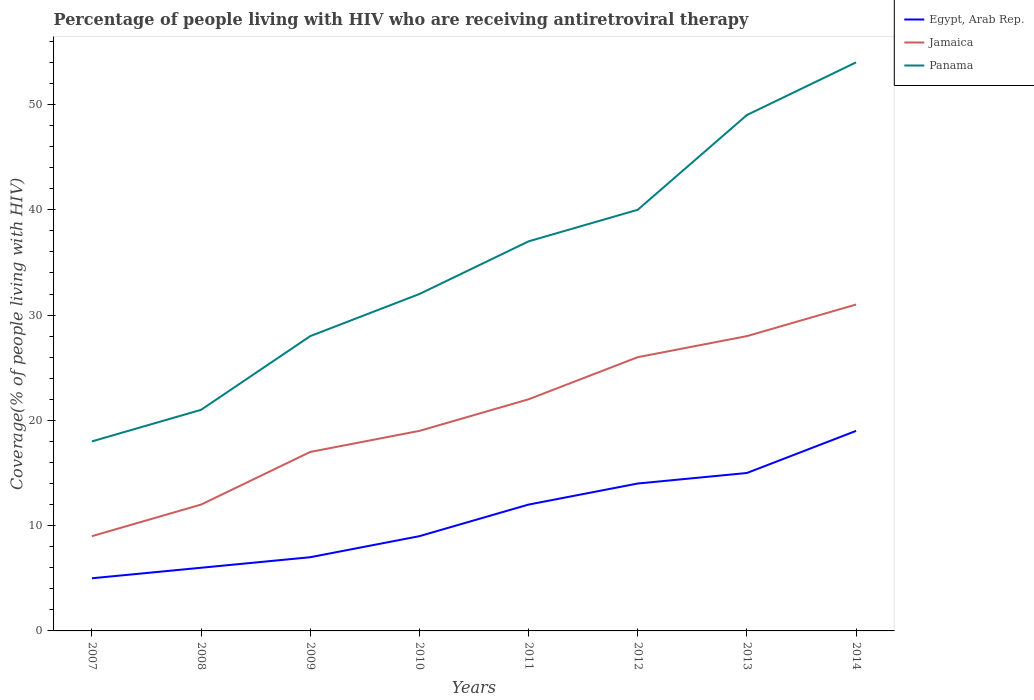How many different coloured lines are there?
Keep it short and to the point. 3. Is the number of lines equal to the number of legend labels?
Your answer should be very brief. Yes. Across all years, what is the maximum percentage of the HIV infected people who are receiving antiretroviral therapy in Panama?
Give a very brief answer. 18. What is the total percentage of the HIV infected people who are receiving antiretroviral therapy in Egypt, Arab Rep. in the graph?
Offer a terse response. -8. What is the difference between the highest and the second highest percentage of the HIV infected people who are receiving antiretroviral therapy in Panama?
Your response must be concise. 36. How many lines are there?
Your answer should be very brief. 3. Are the values on the major ticks of Y-axis written in scientific E-notation?
Give a very brief answer. No. Does the graph contain any zero values?
Your answer should be very brief. No. Does the graph contain grids?
Offer a terse response. No. Where does the legend appear in the graph?
Provide a short and direct response. Top right. How many legend labels are there?
Provide a short and direct response. 3. How are the legend labels stacked?
Ensure brevity in your answer.  Vertical. What is the title of the graph?
Offer a very short reply. Percentage of people living with HIV who are receiving antiretroviral therapy. What is the label or title of the Y-axis?
Your response must be concise. Coverage(% of people living with HIV). What is the Coverage(% of people living with HIV) in Egypt, Arab Rep. in 2007?
Provide a short and direct response. 5. What is the Coverage(% of people living with HIV) of Jamaica in 2007?
Your answer should be very brief. 9. What is the Coverage(% of people living with HIV) in Panama in 2007?
Your answer should be compact. 18. What is the Coverage(% of people living with HIV) of Egypt, Arab Rep. in 2008?
Provide a short and direct response. 6. What is the Coverage(% of people living with HIV) in Jamaica in 2009?
Ensure brevity in your answer.  17. What is the Coverage(% of people living with HIV) in Panama in 2009?
Your response must be concise. 28. What is the Coverage(% of people living with HIV) in Egypt, Arab Rep. in 2010?
Make the answer very short. 9. What is the Coverage(% of people living with HIV) in Panama in 2010?
Your answer should be compact. 32. What is the Coverage(% of people living with HIV) in Jamaica in 2011?
Provide a short and direct response. 22. What is the Coverage(% of people living with HIV) of Panama in 2011?
Offer a terse response. 37. What is the Coverage(% of people living with HIV) of Egypt, Arab Rep. in 2012?
Provide a short and direct response. 14. What is the Coverage(% of people living with HIV) in Panama in 2012?
Provide a short and direct response. 40. What is the Coverage(% of people living with HIV) of Egypt, Arab Rep. in 2013?
Give a very brief answer. 15. What is the Coverage(% of people living with HIV) in Jamaica in 2013?
Your answer should be very brief. 28. What is the Coverage(% of people living with HIV) in Panama in 2013?
Your response must be concise. 49. What is the Coverage(% of people living with HIV) in Jamaica in 2014?
Provide a short and direct response. 31. Across all years, what is the maximum Coverage(% of people living with HIV) of Jamaica?
Provide a succinct answer. 31. Across all years, what is the maximum Coverage(% of people living with HIV) in Panama?
Keep it short and to the point. 54. Across all years, what is the minimum Coverage(% of people living with HIV) in Jamaica?
Your answer should be very brief. 9. What is the total Coverage(% of people living with HIV) in Egypt, Arab Rep. in the graph?
Your answer should be compact. 87. What is the total Coverage(% of people living with HIV) in Jamaica in the graph?
Provide a succinct answer. 164. What is the total Coverage(% of people living with HIV) of Panama in the graph?
Provide a succinct answer. 279. What is the difference between the Coverage(% of people living with HIV) of Egypt, Arab Rep. in 2007 and that in 2008?
Offer a very short reply. -1. What is the difference between the Coverage(% of people living with HIV) of Panama in 2007 and that in 2008?
Keep it short and to the point. -3. What is the difference between the Coverage(% of people living with HIV) of Jamaica in 2007 and that in 2009?
Provide a succinct answer. -8. What is the difference between the Coverage(% of people living with HIV) in Egypt, Arab Rep. in 2007 and that in 2010?
Offer a terse response. -4. What is the difference between the Coverage(% of people living with HIV) in Jamaica in 2007 and that in 2010?
Offer a very short reply. -10. What is the difference between the Coverage(% of people living with HIV) of Egypt, Arab Rep. in 2007 and that in 2011?
Your answer should be compact. -7. What is the difference between the Coverage(% of people living with HIV) in Jamaica in 2007 and that in 2011?
Offer a very short reply. -13. What is the difference between the Coverage(% of people living with HIV) in Panama in 2007 and that in 2011?
Your answer should be very brief. -19. What is the difference between the Coverage(% of people living with HIV) of Jamaica in 2007 and that in 2012?
Your answer should be compact. -17. What is the difference between the Coverage(% of people living with HIV) of Panama in 2007 and that in 2012?
Your answer should be very brief. -22. What is the difference between the Coverage(% of people living with HIV) of Panama in 2007 and that in 2013?
Offer a terse response. -31. What is the difference between the Coverage(% of people living with HIV) in Egypt, Arab Rep. in 2007 and that in 2014?
Your answer should be compact. -14. What is the difference between the Coverage(% of people living with HIV) in Panama in 2007 and that in 2014?
Offer a terse response. -36. What is the difference between the Coverage(% of people living with HIV) of Jamaica in 2008 and that in 2009?
Your response must be concise. -5. What is the difference between the Coverage(% of people living with HIV) of Egypt, Arab Rep. in 2008 and that in 2010?
Keep it short and to the point. -3. What is the difference between the Coverage(% of people living with HIV) in Panama in 2008 and that in 2010?
Your answer should be very brief. -11. What is the difference between the Coverage(% of people living with HIV) of Jamaica in 2008 and that in 2011?
Offer a very short reply. -10. What is the difference between the Coverage(% of people living with HIV) of Egypt, Arab Rep. in 2008 and that in 2013?
Your response must be concise. -9. What is the difference between the Coverage(% of people living with HIV) of Jamaica in 2008 and that in 2013?
Make the answer very short. -16. What is the difference between the Coverage(% of people living with HIV) in Egypt, Arab Rep. in 2008 and that in 2014?
Provide a succinct answer. -13. What is the difference between the Coverage(% of people living with HIV) of Jamaica in 2008 and that in 2014?
Ensure brevity in your answer.  -19. What is the difference between the Coverage(% of people living with HIV) in Panama in 2008 and that in 2014?
Provide a succinct answer. -33. What is the difference between the Coverage(% of people living with HIV) in Jamaica in 2009 and that in 2010?
Provide a succinct answer. -2. What is the difference between the Coverage(% of people living with HIV) in Panama in 2009 and that in 2010?
Provide a short and direct response. -4. What is the difference between the Coverage(% of people living with HIV) in Jamaica in 2009 and that in 2011?
Your response must be concise. -5. What is the difference between the Coverage(% of people living with HIV) of Jamaica in 2009 and that in 2012?
Make the answer very short. -9. What is the difference between the Coverage(% of people living with HIV) in Panama in 2009 and that in 2012?
Ensure brevity in your answer.  -12. What is the difference between the Coverage(% of people living with HIV) in Egypt, Arab Rep. in 2009 and that in 2014?
Your response must be concise. -12. What is the difference between the Coverage(% of people living with HIV) in Jamaica in 2009 and that in 2014?
Give a very brief answer. -14. What is the difference between the Coverage(% of people living with HIV) of Jamaica in 2010 and that in 2011?
Make the answer very short. -3. What is the difference between the Coverage(% of people living with HIV) in Egypt, Arab Rep. in 2010 and that in 2012?
Offer a very short reply. -5. What is the difference between the Coverage(% of people living with HIV) of Jamaica in 2010 and that in 2012?
Give a very brief answer. -7. What is the difference between the Coverage(% of people living with HIV) in Jamaica in 2010 and that in 2013?
Your answer should be compact. -9. What is the difference between the Coverage(% of people living with HIV) of Panama in 2010 and that in 2013?
Provide a succinct answer. -17. What is the difference between the Coverage(% of people living with HIV) in Egypt, Arab Rep. in 2010 and that in 2014?
Your answer should be compact. -10. What is the difference between the Coverage(% of people living with HIV) in Panama in 2010 and that in 2014?
Ensure brevity in your answer.  -22. What is the difference between the Coverage(% of people living with HIV) in Jamaica in 2011 and that in 2012?
Offer a terse response. -4. What is the difference between the Coverage(% of people living with HIV) of Jamaica in 2011 and that in 2013?
Keep it short and to the point. -6. What is the difference between the Coverage(% of people living with HIV) of Egypt, Arab Rep. in 2011 and that in 2014?
Your answer should be compact. -7. What is the difference between the Coverage(% of people living with HIV) in Jamaica in 2012 and that in 2013?
Give a very brief answer. -2. What is the difference between the Coverage(% of people living with HIV) of Panama in 2012 and that in 2013?
Make the answer very short. -9. What is the difference between the Coverage(% of people living with HIV) of Egypt, Arab Rep. in 2012 and that in 2014?
Offer a very short reply. -5. What is the difference between the Coverage(% of people living with HIV) of Jamaica in 2012 and that in 2014?
Offer a very short reply. -5. What is the difference between the Coverage(% of people living with HIV) of Jamaica in 2013 and that in 2014?
Provide a short and direct response. -3. What is the difference between the Coverage(% of people living with HIV) in Panama in 2013 and that in 2014?
Offer a terse response. -5. What is the difference between the Coverage(% of people living with HIV) in Egypt, Arab Rep. in 2007 and the Coverage(% of people living with HIV) in Jamaica in 2008?
Give a very brief answer. -7. What is the difference between the Coverage(% of people living with HIV) in Egypt, Arab Rep. in 2007 and the Coverage(% of people living with HIV) in Jamaica in 2009?
Your response must be concise. -12. What is the difference between the Coverage(% of people living with HIV) of Egypt, Arab Rep. in 2007 and the Coverage(% of people living with HIV) of Panama in 2009?
Your response must be concise. -23. What is the difference between the Coverage(% of people living with HIV) of Jamaica in 2007 and the Coverage(% of people living with HIV) of Panama in 2010?
Your answer should be compact. -23. What is the difference between the Coverage(% of people living with HIV) in Egypt, Arab Rep. in 2007 and the Coverage(% of people living with HIV) in Jamaica in 2011?
Your answer should be very brief. -17. What is the difference between the Coverage(% of people living with HIV) of Egypt, Arab Rep. in 2007 and the Coverage(% of people living with HIV) of Panama in 2011?
Offer a terse response. -32. What is the difference between the Coverage(% of people living with HIV) of Egypt, Arab Rep. in 2007 and the Coverage(% of people living with HIV) of Panama in 2012?
Ensure brevity in your answer.  -35. What is the difference between the Coverage(% of people living with HIV) of Jamaica in 2007 and the Coverage(% of people living with HIV) of Panama in 2012?
Give a very brief answer. -31. What is the difference between the Coverage(% of people living with HIV) in Egypt, Arab Rep. in 2007 and the Coverage(% of people living with HIV) in Jamaica in 2013?
Your answer should be very brief. -23. What is the difference between the Coverage(% of people living with HIV) of Egypt, Arab Rep. in 2007 and the Coverage(% of people living with HIV) of Panama in 2013?
Your response must be concise. -44. What is the difference between the Coverage(% of people living with HIV) in Jamaica in 2007 and the Coverage(% of people living with HIV) in Panama in 2013?
Keep it short and to the point. -40. What is the difference between the Coverage(% of people living with HIV) of Egypt, Arab Rep. in 2007 and the Coverage(% of people living with HIV) of Jamaica in 2014?
Make the answer very short. -26. What is the difference between the Coverage(% of people living with HIV) in Egypt, Arab Rep. in 2007 and the Coverage(% of people living with HIV) in Panama in 2014?
Give a very brief answer. -49. What is the difference between the Coverage(% of people living with HIV) in Jamaica in 2007 and the Coverage(% of people living with HIV) in Panama in 2014?
Provide a succinct answer. -45. What is the difference between the Coverage(% of people living with HIV) in Egypt, Arab Rep. in 2008 and the Coverage(% of people living with HIV) in Jamaica in 2010?
Your answer should be compact. -13. What is the difference between the Coverage(% of people living with HIV) of Egypt, Arab Rep. in 2008 and the Coverage(% of people living with HIV) of Panama in 2010?
Ensure brevity in your answer.  -26. What is the difference between the Coverage(% of people living with HIV) in Jamaica in 2008 and the Coverage(% of people living with HIV) in Panama in 2010?
Keep it short and to the point. -20. What is the difference between the Coverage(% of people living with HIV) of Egypt, Arab Rep. in 2008 and the Coverage(% of people living with HIV) of Jamaica in 2011?
Ensure brevity in your answer.  -16. What is the difference between the Coverage(% of people living with HIV) of Egypt, Arab Rep. in 2008 and the Coverage(% of people living with HIV) of Panama in 2011?
Your answer should be compact. -31. What is the difference between the Coverage(% of people living with HIV) in Egypt, Arab Rep. in 2008 and the Coverage(% of people living with HIV) in Panama in 2012?
Provide a short and direct response. -34. What is the difference between the Coverage(% of people living with HIV) of Egypt, Arab Rep. in 2008 and the Coverage(% of people living with HIV) of Jamaica in 2013?
Your response must be concise. -22. What is the difference between the Coverage(% of people living with HIV) of Egypt, Arab Rep. in 2008 and the Coverage(% of people living with HIV) of Panama in 2013?
Give a very brief answer. -43. What is the difference between the Coverage(% of people living with HIV) in Jamaica in 2008 and the Coverage(% of people living with HIV) in Panama in 2013?
Your response must be concise. -37. What is the difference between the Coverage(% of people living with HIV) of Egypt, Arab Rep. in 2008 and the Coverage(% of people living with HIV) of Jamaica in 2014?
Offer a very short reply. -25. What is the difference between the Coverage(% of people living with HIV) of Egypt, Arab Rep. in 2008 and the Coverage(% of people living with HIV) of Panama in 2014?
Your answer should be compact. -48. What is the difference between the Coverage(% of people living with HIV) of Jamaica in 2008 and the Coverage(% of people living with HIV) of Panama in 2014?
Ensure brevity in your answer.  -42. What is the difference between the Coverage(% of people living with HIV) in Egypt, Arab Rep. in 2009 and the Coverage(% of people living with HIV) in Panama in 2010?
Offer a terse response. -25. What is the difference between the Coverage(% of people living with HIV) of Egypt, Arab Rep. in 2009 and the Coverage(% of people living with HIV) of Jamaica in 2011?
Provide a short and direct response. -15. What is the difference between the Coverage(% of people living with HIV) in Egypt, Arab Rep. in 2009 and the Coverage(% of people living with HIV) in Panama in 2011?
Keep it short and to the point. -30. What is the difference between the Coverage(% of people living with HIV) in Egypt, Arab Rep. in 2009 and the Coverage(% of people living with HIV) in Panama in 2012?
Your response must be concise. -33. What is the difference between the Coverage(% of people living with HIV) in Egypt, Arab Rep. in 2009 and the Coverage(% of people living with HIV) in Jamaica in 2013?
Provide a succinct answer. -21. What is the difference between the Coverage(% of people living with HIV) in Egypt, Arab Rep. in 2009 and the Coverage(% of people living with HIV) in Panama in 2013?
Keep it short and to the point. -42. What is the difference between the Coverage(% of people living with HIV) in Jamaica in 2009 and the Coverage(% of people living with HIV) in Panama in 2013?
Your answer should be very brief. -32. What is the difference between the Coverage(% of people living with HIV) of Egypt, Arab Rep. in 2009 and the Coverage(% of people living with HIV) of Panama in 2014?
Your answer should be very brief. -47. What is the difference between the Coverage(% of people living with HIV) of Jamaica in 2009 and the Coverage(% of people living with HIV) of Panama in 2014?
Ensure brevity in your answer.  -37. What is the difference between the Coverage(% of people living with HIV) of Egypt, Arab Rep. in 2010 and the Coverage(% of people living with HIV) of Panama in 2011?
Provide a short and direct response. -28. What is the difference between the Coverage(% of people living with HIV) in Egypt, Arab Rep. in 2010 and the Coverage(% of people living with HIV) in Panama in 2012?
Make the answer very short. -31. What is the difference between the Coverage(% of people living with HIV) of Egypt, Arab Rep. in 2010 and the Coverage(% of people living with HIV) of Jamaica in 2013?
Ensure brevity in your answer.  -19. What is the difference between the Coverage(% of people living with HIV) of Egypt, Arab Rep. in 2010 and the Coverage(% of people living with HIV) of Panama in 2013?
Your answer should be compact. -40. What is the difference between the Coverage(% of people living with HIV) in Jamaica in 2010 and the Coverage(% of people living with HIV) in Panama in 2013?
Give a very brief answer. -30. What is the difference between the Coverage(% of people living with HIV) in Egypt, Arab Rep. in 2010 and the Coverage(% of people living with HIV) in Jamaica in 2014?
Your answer should be very brief. -22. What is the difference between the Coverage(% of people living with HIV) of Egypt, Arab Rep. in 2010 and the Coverage(% of people living with HIV) of Panama in 2014?
Make the answer very short. -45. What is the difference between the Coverage(% of people living with HIV) in Jamaica in 2010 and the Coverage(% of people living with HIV) in Panama in 2014?
Your answer should be compact. -35. What is the difference between the Coverage(% of people living with HIV) of Egypt, Arab Rep. in 2011 and the Coverage(% of people living with HIV) of Panama in 2012?
Make the answer very short. -28. What is the difference between the Coverage(% of people living with HIV) in Egypt, Arab Rep. in 2011 and the Coverage(% of people living with HIV) in Panama in 2013?
Your response must be concise. -37. What is the difference between the Coverage(% of people living with HIV) in Jamaica in 2011 and the Coverage(% of people living with HIV) in Panama in 2013?
Ensure brevity in your answer.  -27. What is the difference between the Coverage(% of people living with HIV) in Egypt, Arab Rep. in 2011 and the Coverage(% of people living with HIV) in Panama in 2014?
Make the answer very short. -42. What is the difference between the Coverage(% of people living with HIV) of Jamaica in 2011 and the Coverage(% of people living with HIV) of Panama in 2014?
Keep it short and to the point. -32. What is the difference between the Coverage(% of people living with HIV) in Egypt, Arab Rep. in 2012 and the Coverage(% of people living with HIV) in Jamaica in 2013?
Your response must be concise. -14. What is the difference between the Coverage(% of people living with HIV) of Egypt, Arab Rep. in 2012 and the Coverage(% of people living with HIV) of Panama in 2013?
Give a very brief answer. -35. What is the difference between the Coverage(% of people living with HIV) in Jamaica in 2012 and the Coverage(% of people living with HIV) in Panama in 2013?
Provide a short and direct response. -23. What is the difference between the Coverage(% of people living with HIV) in Egypt, Arab Rep. in 2012 and the Coverage(% of people living with HIV) in Jamaica in 2014?
Ensure brevity in your answer.  -17. What is the difference between the Coverage(% of people living with HIV) in Egypt, Arab Rep. in 2012 and the Coverage(% of people living with HIV) in Panama in 2014?
Offer a terse response. -40. What is the difference between the Coverage(% of people living with HIV) in Jamaica in 2012 and the Coverage(% of people living with HIV) in Panama in 2014?
Your response must be concise. -28. What is the difference between the Coverage(% of people living with HIV) of Egypt, Arab Rep. in 2013 and the Coverage(% of people living with HIV) of Jamaica in 2014?
Make the answer very short. -16. What is the difference between the Coverage(% of people living with HIV) in Egypt, Arab Rep. in 2013 and the Coverage(% of people living with HIV) in Panama in 2014?
Your answer should be compact. -39. What is the average Coverage(% of people living with HIV) of Egypt, Arab Rep. per year?
Your response must be concise. 10.88. What is the average Coverage(% of people living with HIV) of Jamaica per year?
Keep it short and to the point. 20.5. What is the average Coverage(% of people living with HIV) in Panama per year?
Offer a very short reply. 34.88. In the year 2007, what is the difference between the Coverage(% of people living with HIV) in Egypt, Arab Rep. and Coverage(% of people living with HIV) in Jamaica?
Ensure brevity in your answer.  -4. In the year 2007, what is the difference between the Coverage(% of people living with HIV) in Egypt, Arab Rep. and Coverage(% of people living with HIV) in Panama?
Your response must be concise. -13. In the year 2008, what is the difference between the Coverage(% of people living with HIV) of Egypt, Arab Rep. and Coverage(% of people living with HIV) of Panama?
Offer a terse response. -15. In the year 2008, what is the difference between the Coverage(% of people living with HIV) of Jamaica and Coverage(% of people living with HIV) of Panama?
Give a very brief answer. -9. In the year 2009, what is the difference between the Coverage(% of people living with HIV) in Egypt, Arab Rep. and Coverage(% of people living with HIV) in Jamaica?
Offer a terse response. -10. In the year 2009, what is the difference between the Coverage(% of people living with HIV) in Egypt, Arab Rep. and Coverage(% of people living with HIV) in Panama?
Your answer should be compact. -21. In the year 2009, what is the difference between the Coverage(% of people living with HIV) of Jamaica and Coverage(% of people living with HIV) of Panama?
Provide a short and direct response. -11. In the year 2010, what is the difference between the Coverage(% of people living with HIV) of Jamaica and Coverage(% of people living with HIV) of Panama?
Your response must be concise. -13. In the year 2011, what is the difference between the Coverage(% of people living with HIV) in Egypt, Arab Rep. and Coverage(% of people living with HIV) in Jamaica?
Make the answer very short. -10. In the year 2011, what is the difference between the Coverage(% of people living with HIV) of Egypt, Arab Rep. and Coverage(% of people living with HIV) of Panama?
Your answer should be compact. -25. In the year 2012, what is the difference between the Coverage(% of people living with HIV) of Egypt, Arab Rep. and Coverage(% of people living with HIV) of Panama?
Offer a very short reply. -26. In the year 2012, what is the difference between the Coverage(% of people living with HIV) of Jamaica and Coverage(% of people living with HIV) of Panama?
Keep it short and to the point. -14. In the year 2013, what is the difference between the Coverage(% of people living with HIV) in Egypt, Arab Rep. and Coverage(% of people living with HIV) in Jamaica?
Your answer should be very brief. -13. In the year 2013, what is the difference between the Coverage(% of people living with HIV) in Egypt, Arab Rep. and Coverage(% of people living with HIV) in Panama?
Give a very brief answer. -34. In the year 2014, what is the difference between the Coverage(% of people living with HIV) of Egypt, Arab Rep. and Coverage(% of people living with HIV) of Jamaica?
Offer a very short reply. -12. In the year 2014, what is the difference between the Coverage(% of people living with HIV) of Egypt, Arab Rep. and Coverage(% of people living with HIV) of Panama?
Offer a very short reply. -35. What is the ratio of the Coverage(% of people living with HIV) in Egypt, Arab Rep. in 2007 to that in 2008?
Give a very brief answer. 0.83. What is the ratio of the Coverage(% of people living with HIV) in Jamaica in 2007 to that in 2008?
Offer a very short reply. 0.75. What is the ratio of the Coverage(% of people living with HIV) of Egypt, Arab Rep. in 2007 to that in 2009?
Your answer should be compact. 0.71. What is the ratio of the Coverage(% of people living with HIV) of Jamaica in 2007 to that in 2009?
Your answer should be compact. 0.53. What is the ratio of the Coverage(% of people living with HIV) in Panama in 2007 to that in 2009?
Provide a short and direct response. 0.64. What is the ratio of the Coverage(% of people living with HIV) in Egypt, Arab Rep. in 2007 to that in 2010?
Your answer should be compact. 0.56. What is the ratio of the Coverage(% of people living with HIV) of Jamaica in 2007 to that in 2010?
Make the answer very short. 0.47. What is the ratio of the Coverage(% of people living with HIV) of Panama in 2007 to that in 2010?
Your response must be concise. 0.56. What is the ratio of the Coverage(% of people living with HIV) of Egypt, Arab Rep. in 2007 to that in 2011?
Ensure brevity in your answer.  0.42. What is the ratio of the Coverage(% of people living with HIV) in Jamaica in 2007 to that in 2011?
Your response must be concise. 0.41. What is the ratio of the Coverage(% of people living with HIV) in Panama in 2007 to that in 2011?
Give a very brief answer. 0.49. What is the ratio of the Coverage(% of people living with HIV) of Egypt, Arab Rep. in 2007 to that in 2012?
Offer a very short reply. 0.36. What is the ratio of the Coverage(% of people living with HIV) in Jamaica in 2007 to that in 2012?
Make the answer very short. 0.35. What is the ratio of the Coverage(% of people living with HIV) of Panama in 2007 to that in 2012?
Offer a terse response. 0.45. What is the ratio of the Coverage(% of people living with HIV) of Jamaica in 2007 to that in 2013?
Make the answer very short. 0.32. What is the ratio of the Coverage(% of people living with HIV) in Panama in 2007 to that in 2013?
Your answer should be very brief. 0.37. What is the ratio of the Coverage(% of people living with HIV) of Egypt, Arab Rep. in 2007 to that in 2014?
Give a very brief answer. 0.26. What is the ratio of the Coverage(% of people living with HIV) of Jamaica in 2007 to that in 2014?
Give a very brief answer. 0.29. What is the ratio of the Coverage(% of people living with HIV) of Egypt, Arab Rep. in 2008 to that in 2009?
Give a very brief answer. 0.86. What is the ratio of the Coverage(% of people living with HIV) in Jamaica in 2008 to that in 2009?
Your answer should be very brief. 0.71. What is the ratio of the Coverage(% of people living with HIV) of Panama in 2008 to that in 2009?
Your answer should be compact. 0.75. What is the ratio of the Coverage(% of people living with HIV) of Egypt, Arab Rep. in 2008 to that in 2010?
Provide a succinct answer. 0.67. What is the ratio of the Coverage(% of people living with HIV) of Jamaica in 2008 to that in 2010?
Provide a short and direct response. 0.63. What is the ratio of the Coverage(% of people living with HIV) in Panama in 2008 to that in 2010?
Make the answer very short. 0.66. What is the ratio of the Coverage(% of people living with HIV) in Jamaica in 2008 to that in 2011?
Your answer should be very brief. 0.55. What is the ratio of the Coverage(% of people living with HIV) in Panama in 2008 to that in 2011?
Give a very brief answer. 0.57. What is the ratio of the Coverage(% of people living with HIV) in Egypt, Arab Rep. in 2008 to that in 2012?
Your answer should be compact. 0.43. What is the ratio of the Coverage(% of people living with HIV) in Jamaica in 2008 to that in 2012?
Your answer should be compact. 0.46. What is the ratio of the Coverage(% of people living with HIV) of Panama in 2008 to that in 2012?
Your answer should be compact. 0.53. What is the ratio of the Coverage(% of people living with HIV) in Jamaica in 2008 to that in 2013?
Give a very brief answer. 0.43. What is the ratio of the Coverage(% of people living with HIV) in Panama in 2008 to that in 2013?
Your answer should be compact. 0.43. What is the ratio of the Coverage(% of people living with HIV) of Egypt, Arab Rep. in 2008 to that in 2014?
Your answer should be very brief. 0.32. What is the ratio of the Coverage(% of people living with HIV) in Jamaica in 2008 to that in 2014?
Ensure brevity in your answer.  0.39. What is the ratio of the Coverage(% of people living with HIV) of Panama in 2008 to that in 2014?
Give a very brief answer. 0.39. What is the ratio of the Coverage(% of people living with HIV) in Jamaica in 2009 to that in 2010?
Provide a succinct answer. 0.89. What is the ratio of the Coverage(% of people living with HIV) in Egypt, Arab Rep. in 2009 to that in 2011?
Provide a short and direct response. 0.58. What is the ratio of the Coverage(% of people living with HIV) in Jamaica in 2009 to that in 2011?
Your answer should be very brief. 0.77. What is the ratio of the Coverage(% of people living with HIV) of Panama in 2009 to that in 2011?
Keep it short and to the point. 0.76. What is the ratio of the Coverage(% of people living with HIV) of Egypt, Arab Rep. in 2009 to that in 2012?
Offer a terse response. 0.5. What is the ratio of the Coverage(% of people living with HIV) of Jamaica in 2009 to that in 2012?
Make the answer very short. 0.65. What is the ratio of the Coverage(% of people living with HIV) in Egypt, Arab Rep. in 2009 to that in 2013?
Offer a terse response. 0.47. What is the ratio of the Coverage(% of people living with HIV) in Jamaica in 2009 to that in 2013?
Offer a terse response. 0.61. What is the ratio of the Coverage(% of people living with HIV) of Egypt, Arab Rep. in 2009 to that in 2014?
Ensure brevity in your answer.  0.37. What is the ratio of the Coverage(% of people living with HIV) in Jamaica in 2009 to that in 2014?
Provide a succinct answer. 0.55. What is the ratio of the Coverage(% of people living with HIV) of Panama in 2009 to that in 2014?
Your response must be concise. 0.52. What is the ratio of the Coverage(% of people living with HIV) of Jamaica in 2010 to that in 2011?
Offer a terse response. 0.86. What is the ratio of the Coverage(% of people living with HIV) in Panama in 2010 to that in 2011?
Provide a short and direct response. 0.86. What is the ratio of the Coverage(% of people living with HIV) in Egypt, Arab Rep. in 2010 to that in 2012?
Make the answer very short. 0.64. What is the ratio of the Coverage(% of people living with HIV) in Jamaica in 2010 to that in 2012?
Give a very brief answer. 0.73. What is the ratio of the Coverage(% of people living with HIV) in Egypt, Arab Rep. in 2010 to that in 2013?
Offer a terse response. 0.6. What is the ratio of the Coverage(% of people living with HIV) of Jamaica in 2010 to that in 2013?
Ensure brevity in your answer.  0.68. What is the ratio of the Coverage(% of people living with HIV) of Panama in 2010 to that in 2013?
Keep it short and to the point. 0.65. What is the ratio of the Coverage(% of people living with HIV) of Egypt, Arab Rep. in 2010 to that in 2014?
Keep it short and to the point. 0.47. What is the ratio of the Coverage(% of people living with HIV) in Jamaica in 2010 to that in 2014?
Your answer should be compact. 0.61. What is the ratio of the Coverage(% of people living with HIV) in Panama in 2010 to that in 2014?
Ensure brevity in your answer.  0.59. What is the ratio of the Coverage(% of people living with HIV) of Jamaica in 2011 to that in 2012?
Keep it short and to the point. 0.85. What is the ratio of the Coverage(% of people living with HIV) of Panama in 2011 to that in 2012?
Provide a succinct answer. 0.93. What is the ratio of the Coverage(% of people living with HIV) in Egypt, Arab Rep. in 2011 to that in 2013?
Make the answer very short. 0.8. What is the ratio of the Coverage(% of people living with HIV) of Jamaica in 2011 to that in 2013?
Your answer should be compact. 0.79. What is the ratio of the Coverage(% of people living with HIV) in Panama in 2011 to that in 2013?
Give a very brief answer. 0.76. What is the ratio of the Coverage(% of people living with HIV) in Egypt, Arab Rep. in 2011 to that in 2014?
Your answer should be compact. 0.63. What is the ratio of the Coverage(% of people living with HIV) of Jamaica in 2011 to that in 2014?
Ensure brevity in your answer.  0.71. What is the ratio of the Coverage(% of people living with HIV) of Panama in 2011 to that in 2014?
Your response must be concise. 0.69. What is the ratio of the Coverage(% of people living with HIV) of Panama in 2012 to that in 2013?
Keep it short and to the point. 0.82. What is the ratio of the Coverage(% of people living with HIV) of Egypt, Arab Rep. in 2012 to that in 2014?
Make the answer very short. 0.74. What is the ratio of the Coverage(% of people living with HIV) of Jamaica in 2012 to that in 2014?
Your answer should be very brief. 0.84. What is the ratio of the Coverage(% of people living with HIV) in Panama in 2012 to that in 2014?
Make the answer very short. 0.74. What is the ratio of the Coverage(% of people living with HIV) in Egypt, Arab Rep. in 2013 to that in 2014?
Provide a short and direct response. 0.79. What is the ratio of the Coverage(% of people living with HIV) in Jamaica in 2013 to that in 2014?
Ensure brevity in your answer.  0.9. What is the ratio of the Coverage(% of people living with HIV) of Panama in 2013 to that in 2014?
Offer a very short reply. 0.91. What is the difference between the highest and the second highest Coverage(% of people living with HIV) in Jamaica?
Offer a very short reply. 3. What is the difference between the highest and the second highest Coverage(% of people living with HIV) of Panama?
Ensure brevity in your answer.  5. What is the difference between the highest and the lowest Coverage(% of people living with HIV) in Panama?
Your response must be concise. 36. 